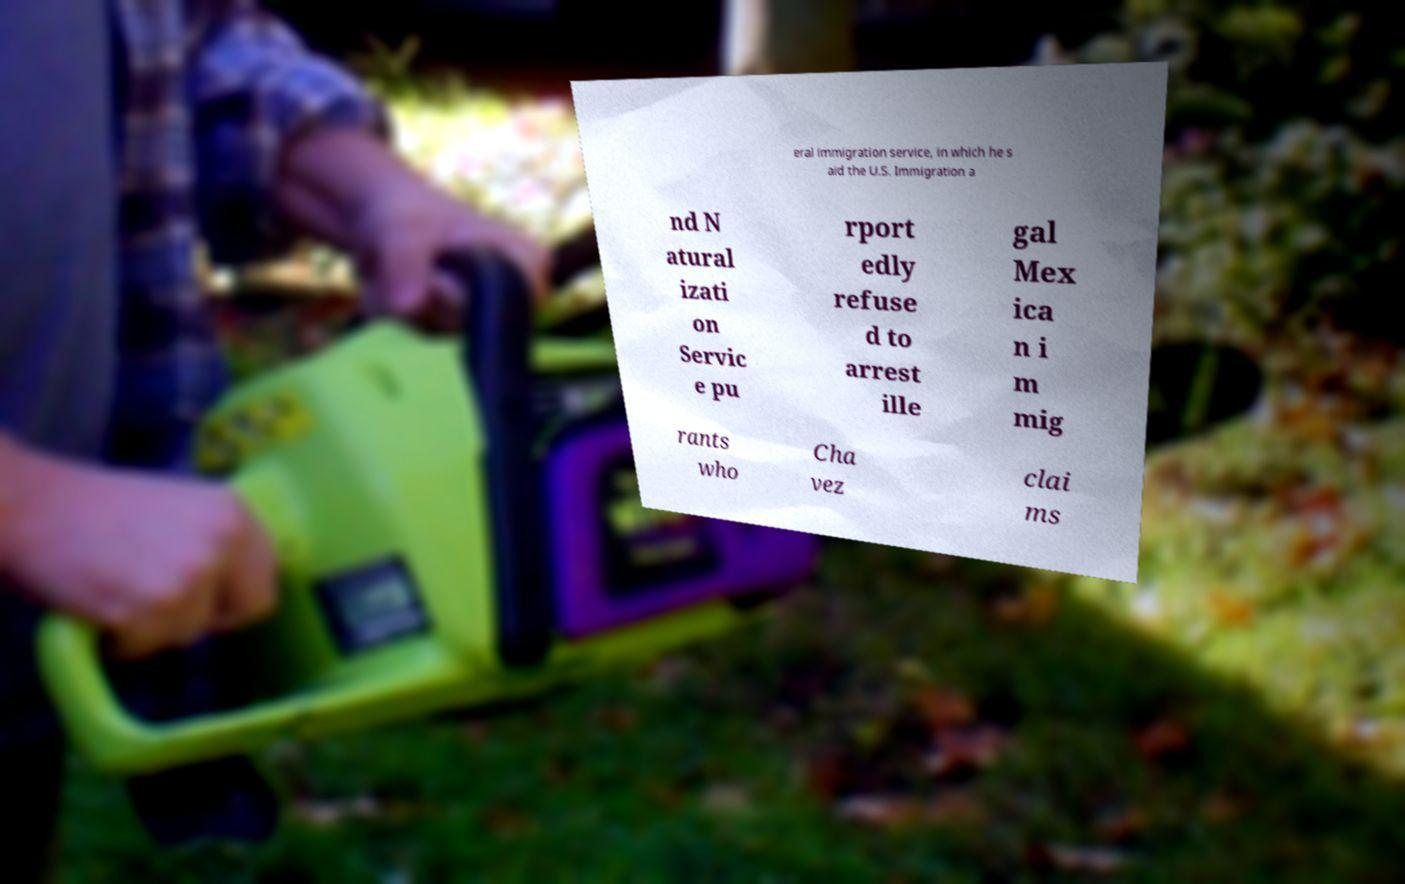Please identify and transcribe the text found in this image. eral immigration service, in which he s aid the U.S. Immigration a nd N atural izati on Servic e pu rport edly refuse d to arrest ille gal Mex ica n i m mig rants who Cha vez clai ms 